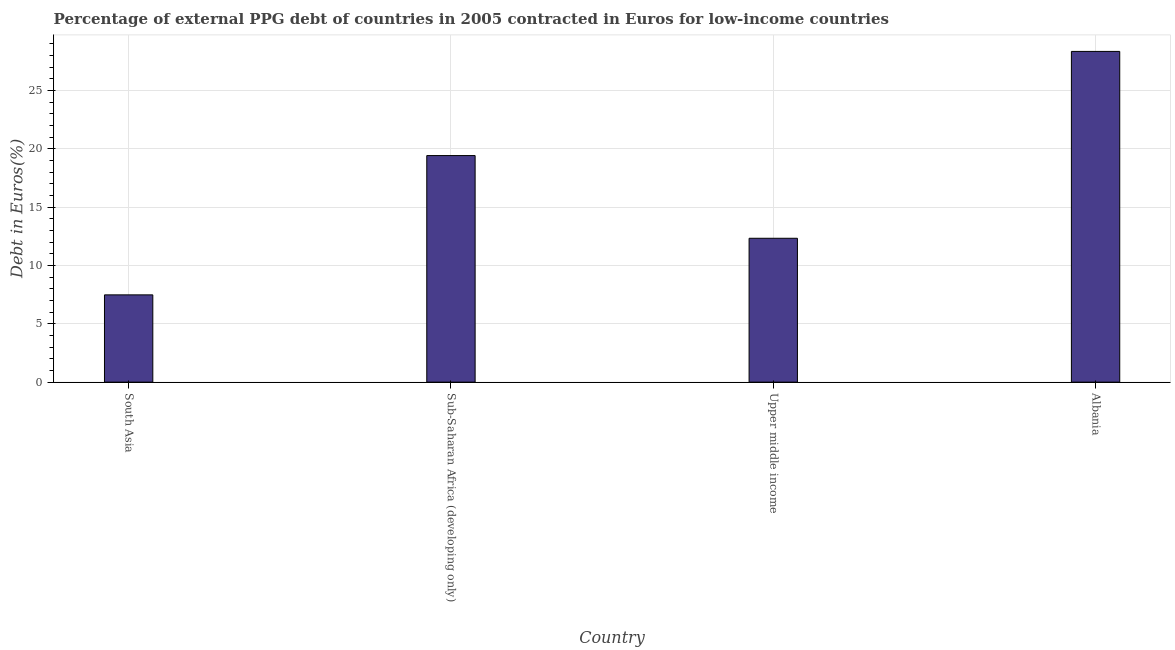Does the graph contain any zero values?
Offer a very short reply. No. What is the title of the graph?
Keep it short and to the point. Percentage of external PPG debt of countries in 2005 contracted in Euros for low-income countries. What is the label or title of the X-axis?
Your answer should be very brief. Country. What is the label or title of the Y-axis?
Provide a short and direct response. Debt in Euros(%). What is the currency composition of ppg debt in South Asia?
Offer a terse response. 7.48. Across all countries, what is the maximum currency composition of ppg debt?
Offer a very short reply. 28.36. Across all countries, what is the minimum currency composition of ppg debt?
Make the answer very short. 7.48. In which country was the currency composition of ppg debt maximum?
Offer a very short reply. Albania. What is the sum of the currency composition of ppg debt?
Keep it short and to the point. 67.6. What is the difference between the currency composition of ppg debt in Albania and South Asia?
Ensure brevity in your answer.  20.87. What is the average currency composition of ppg debt per country?
Your response must be concise. 16.9. What is the median currency composition of ppg debt?
Keep it short and to the point. 15.88. What is the ratio of the currency composition of ppg debt in Albania to that in Sub-Saharan Africa (developing only)?
Your response must be concise. 1.46. Is the currency composition of ppg debt in South Asia less than that in Upper middle income?
Provide a short and direct response. Yes. Is the difference between the currency composition of ppg debt in South Asia and Sub-Saharan Africa (developing only) greater than the difference between any two countries?
Keep it short and to the point. No. What is the difference between the highest and the second highest currency composition of ppg debt?
Keep it short and to the point. 8.93. Is the sum of the currency composition of ppg debt in Albania and Upper middle income greater than the maximum currency composition of ppg debt across all countries?
Provide a succinct answer. Yes. What is the difference between the highest and the lowest currency composition of ppg debt?
Your answer should be compact. 20.87. In how many countries, is the currency composition of ppg debt greater than the average currency composition of ppg debt taken over all countries?
Provide a short and direct response. 2. What is the difference between two consecutive major ticks on the Y-axis?
Make the answer very short. 5. What is the Debt in Euros(%) in South Asia?
Give a very brief answer. 7.48. What is the Debt in Euros(%) in Sub-Saharan Africa (developing only)?
Your answer should be compact. 19.43. What is the Debt in Euros(%) in Upper middle income?
Provide a succinct answer. 12.34. What is the Debt in Euros(%) of Albania?
Provide a succinct answer. 28.36. What is the difference between the Debt in Euros(%) in South Asia and Sub-Saharan Africa (developing only)?
Your answer should be compact. -11.94. What is the difference between the Debt in Euros(%) in South Asia and Upper middle income?
Make the answer very short. -4.85. What is the difference between the Debt in Euros(%) in South Asia and Albania?
Ensure brevity in your answer.  -20.87. What is the difference between the Debt in Euros(%) in Sub-Saharan Africa (developing only) and Upper middle income?
Make the answer very short. 7.09. What is the difference between the Debt in Euros(%) in Sub-Saharan Africa (developing only) and Albania?
Ensure brevity in your answer.  -8.93. What is the difference between the Debt in Euros(%) in Upper middle income and Albania?
Give a very brief answer. -16.02. What is the ratio of the Debt in Euros(%) in South Asia to that in Sub-Saharan Africa (developing only)?
Offer a very short reply. 0.39. What is the ratio of the Debt in Euros(%) in South Asia to that in Upper middle income?
Your answer should be very brief. 0.61. What is the ratio of the Debt in Euros(%) in South Asia to that in Albania?
Offer a terse response. 0.26. What is the ratio of the Debt in Euros(%) in Sub-Saharan Africa (developing only) to that in Upper middle income?
Your response must be concise. 1.57. What is the ratio of the Debt in Euros(%) in Sub-Saharan Africa (developing only) to that in Albania?
Keep it short and to the point. 0.69. What is the ratio of the Debt in Euros(%) in Upper middle income to that in Albania?
Provide a short and direct response. 0.43. 